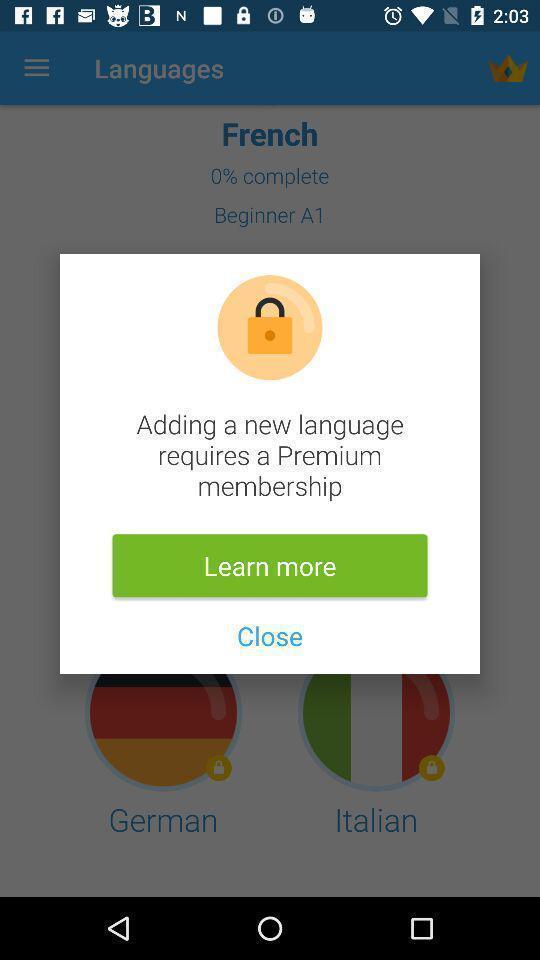Summarize the main components in this picture. Pop-up about adding a new language. 